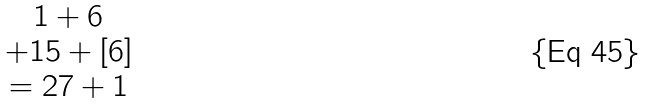Convert formula to latex. <formula><loc_0><loc_0><loc_500><loc_500>\begin{matrix} 1 + 6 \\ + 1 5 + [ 6 ] \\ = { 2 7 } + { 1 } \end{matrix}</formula> 